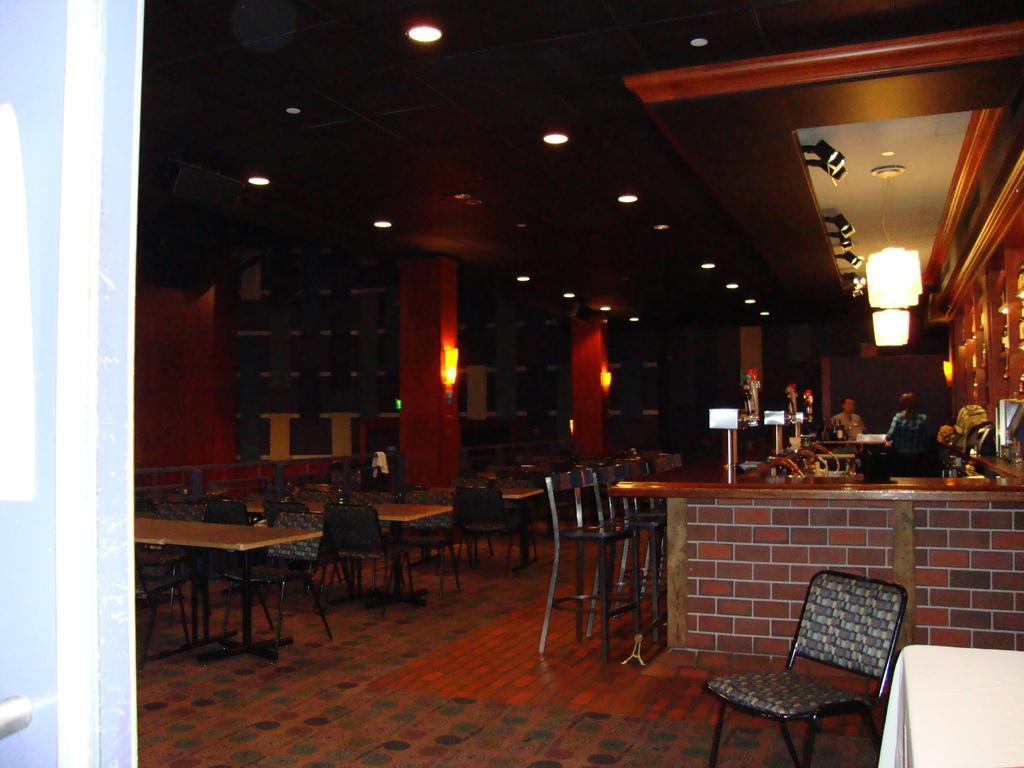Describe this image in one or two sentences. In the picture I can see the tables and chairs on the floor. I can see two persons on the right side. There is a lighting arrangement on the roof. 